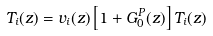<formula> <loc_0><loc_0><loc_500><loc_500>T _ { i } ( z ) = v _ { i } ( z ) \left [ 1 + G _ { 0 } ^ { P } ( z ) \right ] T _ { i } ( z )</formula> 